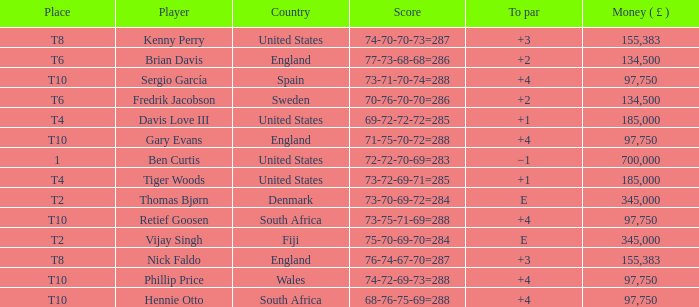What is the To Par of Fredrik Jacobson? 2.0. 